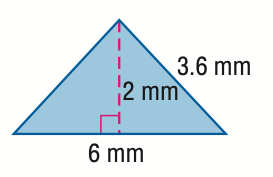Question: Find the area of the triangle. Round to the nearest tenth if necessary.
Choices:
A. 6
B. 12
C. 13.2
D. 24
Answer with the letter. Answer: A Question: Find the perimeter of the triangle. Round to the nearest tenth if necessary.
Choices:
A. 6
B. 9.6
C. 12
D. 13.2
Answer with the letter. Answer: D 